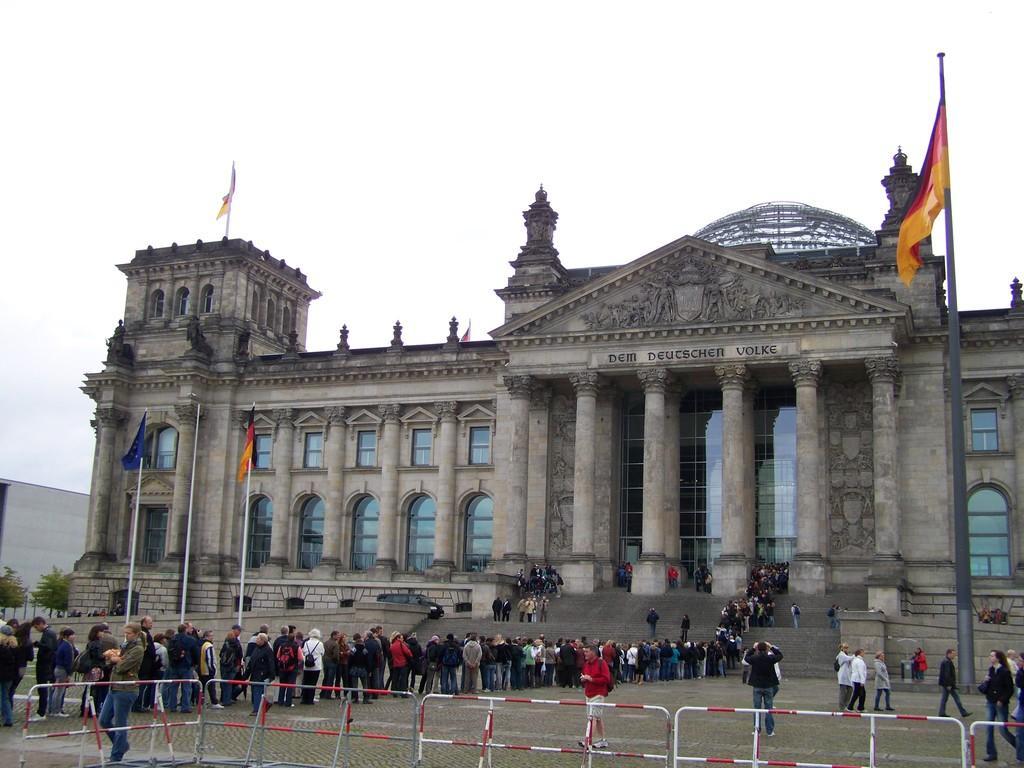Describe this image in one or two sentences. In this image there are a few people standing in a queue in front of a building, there are flag posts in front of the building, In front of the building there is a closed mesh fencing. 